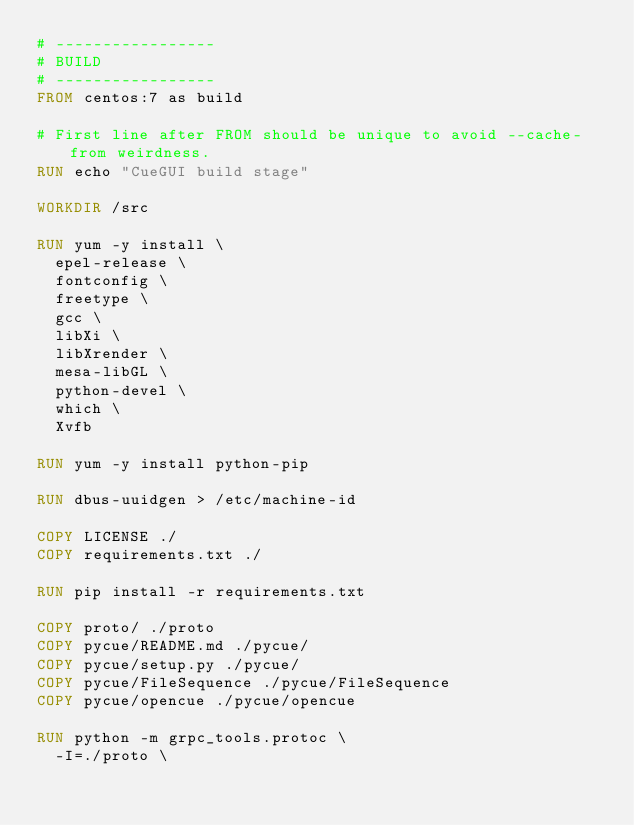Convert code to text. <code><loc_0><loc_0><loc_500><loc_500><_Dockerfile_># -----------------
# BUILD
# -----------------
FROM centos:7 as build

# First line after FROM should be unique to avoid --cache-from weirdness.
RUN echo "CueGUI build stage"

WORKDIR /src

RUN yum -y install \
  epel-release \
  fontconfig \
  freetype \
  gcc \
  libXi \
  libXrender \
  mesa-libGL \
  python-devel \
  which \
  Xvfb

RUN yum -y install python-pip

RUN dbus-uuidgen > /etc/machine-id

COPY LICENSE ./
COPY requirements.txt ./

RUN pip install -r requirements.txt

COPY proto/ ./proto
COPY pycue/README.md ./pycue/
COPY pycue/setup.py ./pycue/
COPY pycue/FileSequence ./pycue/FileSequence
COPY pycue/opencue ./pycue/opencue

RUN python -m grpc_tools.protoc \
  -I=./proto \</code> 